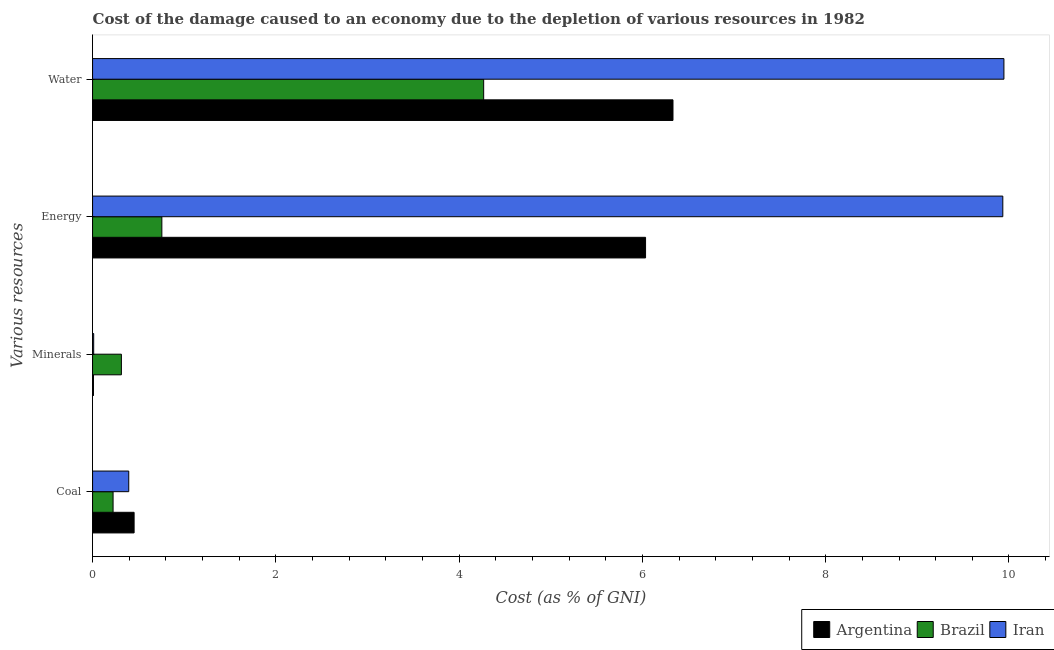How many bars are there on the 4th tick from the top?
Offer a very short reply. 3. What is the label of the 4th group of bars from the top?
Offer a terse response. Coal. What is the cost of damage due to depletion of coal in Iran?
Your response must be concise. 0.39. Across all countries, what is the maximum cost of damage due to depletion of minerals?
Keep it short and to the point. 0.31. Across all countries, what is the minimum cost of damage due to depletion of coal?
Provide a short and direct response. 0.22. In which country was the cost of damage due to depletion of minerals maximum?
Your response must be concise. Brazil. What is the total cost of damage due to depletion of coal in the graph?
Keep it short and to the point. 1.07. What is the difference between the cost of damage due to depletion of energy in Argentina and that in Iran?
Offer a terse response. -3.9. What is the difference between the cost of damage due to depletion of coal in Brazil and the cost of damage due to depletion of minerals in Argentina?
Your answer should be very brief. 0.21. What is the average cost of damage due to depletion of coal per country?
Provide a succinct answer. 0.36. What is the difference between the cost of damage due to depletion of water and cost of damage due to depletion of energy in Argentina?
Ensure brevity in your answer.  0.3. What is the ratio of the cost of damage due to depletion of coal in Brazil to that in Iran?
Make the answer very short. 0.57. Is the cost of damage due to depletion of minerals in Brazil less than that in Iran?
Provide a succinct answer. No. Is the difference between the cost of damage due to depletion of coal in Brazil and Argentina greater than the difference between the cost of damage due to depletion of minerals in Brazil and Argentina?
Ensure brevity in your answer.  No. What is the difference between the highest and the second highest cost of damage due to depletion of minerals?
Offer a very short reply. 0.3. What is the difference between the highest and the lowest cost of damage due to depletion of water?
Your answer should be very brief. 5.68. What does the 1st bar from the top in Minerals represents?
Your response must be concise. Iran. What does the 1st bar from the bottom in Water represents?
Offer a very short reply. Argentina. Is it the case that in every country, the sum of the cost of damage due to depletion of coal and cost of damage due to depletion of minerals is greater than the cost of damage due to depletion of energy?
Give a very brief answer. No. Are all the bars in the graph horizontal?
Ensure brevity in your answer.  Yes. How many countries are there in the graph?
Keep it short and to the point. 3. What is the difference between two consecutive major ticks on the X-axis?
Provide a short and direct response. 2. Does the graph contain grids?
Your response must be concise. No. What is the title of the graph?
Make the answer very short. Cost of the damage caused to an economy due to the depletion of various resources in 1982 . What is the label or title of the X-axis?
Make the answer very short. Cost (as % of GNI). What is the label or title of the Y-axis?
Provide a short and direct response. Various resources. What is the Cost (as % of GNI) in Argentina in Coal?
Provide a succinct answer. 0.45. What is the Cost (as % of GNI) in Brazil in Coal?
Your answer should be compact. 0.22. What is the Cost (as % of GNI) in Iran in Coal?
Offer a very short reply. 0.39. What is the Cost (as % of GNI) in Argentina in Minerals?
Keep it short and to the point. 0.01. What is the Cost (as % of GNI) of Brazil in Minerals?
Offer a terse response. 0.31. What is the Cost (as % of GNI) of Iran in Minerals?
Keep it short and to the point. 0.01. What is the Cost (as % of GNI) in Argentina in Energy?
Offer a very short reply. 6.03. What is the Cost (as % of GNI) of Brazil in Energy?
Ensure brevity in your answer.  0.76. What is the Cost (as % of GNI) of Iran in Energy?
Provide a succinct answer. 9.93. What is the Cost (as % of GNI) in Argentina in Water?
Your response must be concise. 6.33. What is the Cost (as % of GNI) in Brazil in Water?
Your answer should be very brief. 4.27. What is the Cost (as % of GNI) in Iran in Water?
Keep it short and to the point. 9.94. Across all Various resources, what is the maximum Cost (as % of GNI) in Argentina?
Make the answer very short. 6.33. Across all Various resources, what is the maximum Cost (as % of GNI) in Brazil?
Give a very brief answer. 4.27. Across all Various resources, what is the maximum Cost (as % of GNI) in Iran?
Offer a very short reply. 9.94. Across all Various resources, what is the minimum Cost (as % of GNI) of Argentina?
Your response must be concise. 0.01. Across all Various resources, what is the minimum Cost (as % of GNI) in Brazil?
Provide a succinct answer. 0.22. Across all Various resources, what is the minimum Cost (as % of GNI) of Iran?
Ensure brevity in your answer.  0.01. What is the total Cost (as % of GNI) in Argentina in the graph?
Your answer should be compact. 12.83. What is the total Cost (as % of GNI) in Brazil in the graph?
Offer a terse response. 5.56. What is the total Cost (as % of GNI) of Iran in the graph?
Make the answer very short. 20.28. What is the difference between the Cost (as % of GNI) of Argentina in Coal and that in Minerals?
Your response must be concise. 0.44. What is the difference between the Cost (as % of GNI) of Brazil in Coal and that in Minerals?
Ensure brevity in your answer.  -0.09. What is the difference between the Cost (as % of GNI) in Iran in Coal and that in Minerals?
Your answer should be very brief. 0.38. What is the difference between the Cost (as % of GNI) in Argentina in Coal and that in Energy?
Provide a succinct answer. -5.58. What is the difference between the Cost (as % of GNI) in Brazil in Coal and that in Energy?
Keep it short and to the point. -0.53. What is the difference between the Cost (as % of GNI) of Iran in Coal and that in Energy?
Provide a succinct answer. -9.54. What is the difference between the Cost (as % of GNI) in Argentina in Coal and that in Water?
Make the answer very short. -5.88. What is the difference between the Cost (as % of GNI) of Brazil in Coal and that in Water?
Make the answer very short. -4.04. What is the difference between the Cost (as % of GNI) in Iran in Coal and that in Water?
Your response must be concise. -9.55. What is the difference between the Cost (as % of GNI) of Argentina in Minerals and that in Energy?
Keep it short and to the point. -6.02. What is the difference between the Cost (as % of GNI) of Brazil in Minerals and that in Energy?
Make the answer very short. -0.44. What is the difference between the Cost (as % of GNI) of Iran in Minerals and that in Energy?
Provide a succinct answer. -9.92. What is the difference between the Cost (as % of GNI) of Argentina in Minerals and that in Water?
Offer a terse response. -6.32. What is the difference between the Cost (as % of GNI) in Brazil in Minerals and that in Water?
Your response must be concise. -3.95. What is the difference between the Cost (as % of GNI) of Iran in Minerals and that in Water?
Your response must be concise. -9.93. What is the difference between the Cost (as % of GNI) in Argentina in Energy and that in Water?
Provide a short and direct response. -0.3. What is the difference between the Cost (as % of GNI) of Brazil in Energy and that in Water?
Your response must be concise. -3.51. What is the difference between the Cost (as % of GNI) in Iran in Energy and that in Water?
Provide a short and direct response. -0.01. What is the difference between the Cost (as % of GNI) of Argentina in Coal and the Cost (as % of GNI) of Brazil in Minerals?
Ensure brevity in your answer.  0.14. What is the difference between the Cost (as % of GNI) of Argentina in Coal and the Cost (as % of GNI) of Iran in Minerals?
Make the answer very short. 0.44. What is the difference between the Cost (as % of GNI) of Brazil in Coal and the Cost (as % of GNI) of Iran in Minerals?
Offer a very short reply. 0.21. What is the difference between the Cost (as % of GNI) of Argentina in Coal and the Cost (as % of GNI) of Brazil in Energy?
Offer a very short reply. -0.3. What is the difference between the Cost (as % of GNI) of Argentina in Coal and the Cost (as % of GNI) of Iran in Energy?
Make the answer very short. -9.48. What is the difference between the Cost (as % of GNI) in Brazil in Coal and the Cost (as % of GNI) in Iran in Energy?
Provide a succinct answer. -9.71. What is the difference between the Cost (as % of GNI) in Argentina in Coal and the Cost (as % of GNI) in Brazil in Water?
Provide a short and direct response. -3.81. What is the difference between the Cost (as % of GNI) in Argentina in Coal and the Cost (as % of GNI) in Iran in Water?
Keep it short and to the point. -9.49. What is the difference between the Cost (as % of GNI) of Brazil in Coal and the Cost (as % of GNI) of Iran in Water?
Offer a terse response. -9.72. What is the difference between the Cost (as % of GNI) of Argentina in Minerals and the Cost (as % of GNI) of Brazil in Energy?
Your answer should be compact. -0.75. What is the difference between the Cost (as % of GNI) in Argentina in Minerals and the Cost (as % of GNI) in Iran in Energy?
Your answer should be compact. -9.92. What is the difference between the Cost (as % of GNI) of Brazil in Minerals and the Cost (as % of GNI) of Iran in Energy?
Provide a succinct answer. -9.62. What is the difference between the Cost (as % of GNI) of Argentina in Minerals and the Cost (as % of GNI) of Brazil in Water?
Make the answer very short. -4.26. What is the difference between the Cost (as % of GNI) in Argentina in Minerals and the Cost (as % of GNI) in Iran in Water?
Keep it short and to the point. -9.94. What is the difference between the Cost (as % of GNI) in Brazil in Minerals and the Cost (as % of GNI) in Iran in Water?
Your answer should be very brief. -9.63. What is the difference between the Cost (as % of GNI) in Argentina in Energy and the Cost (as % of GNI) in Brazil in Water?
Your answer should be compact. 1.77. What is the difference between the Cost (as % of GNI) of Argentina in Energy and the Cost (as % of GNI) of Iran in Water?
Offer a very short reply. -3.91. What is the difference between the Cost (as % of GNI) of Brazil in Energy and the Cost (as % of GNI) of Iran in Water?
Your answer should be very brief. -9.19. What is the average Cost (as % of GNI) of Argentina per Various resources?
Ensure brevity in your answer.  3.21. What is the average Cost (as % of GNI) in Brazil per Various resources?
Your answer should be very brief. 1.39. What is the average Cost (as % of GNI) in Iran per Various resources?
Offer a very short reply. 5.07. What is the difference between the Cost (as % of GNI) in Argentina and Cost (as % of GNI) in Brazil in Coal?
Give a very brief answer. 0.23. What is the difference between the Cost (as % of GNI) of Argentina and Cost (as % of GNI) of Iran in Coal?
Your response must be concise. 0.06. What is the difference between the Cost (as % of GNI) of Brazil and Cost (as % of GNI) of Iran in Coal?
Keep it short and to the point. -0.17. What is the difference between the Cost (as % of GNI) of Argentina and Cost (as % of GNI) of Brazil in Minerals?
Ensure brevity in your answer.  -0.3. What is the difference between the Cost (as % of GNI) in Argentina and Cost (as % of GNI) in Iran in Minerals?
Give a very brief answer. -0. What is the difference between the Cost (as % of GNI) in Brazil and Cost (as % of GNI) in Iran in Minerals?
Offer a terse response. 0.3. What is the difference between the Cost (as % of GNI) in Argentina and Cost (as % of GNI) in Brazil in Energy?
Your response must be concise. 5.28. What is the difference between the Cost (as % of GNI) of Argentina and Cost (as % of GNI) of Iran in Energy?
Keep it short and to the point. -3.9. What is the difference between the Cost (as % of GNI) of Brazil and Cost (as % of GNI) of Iran in Energy?
Provide a succinct answer. -9.18. What is the difference between the Cost (as % of GNI) in Argentina and Cost (as % of GNI) in Brazil in Water?
Provide a succinct answer. 2.07. What is the difference between the Cost (as % of GNI) in Argentina and Cost (as % of GNI) in Iran in Water?
Give a very brief answer. -3.61. What is the difference between the Cost (as % of GNI) of Brazil and Cost (as % of GNI) of Iran in Water?
Make the answer very short. -5.68. What is the ratio of the Cost (as % of GNI) of Argentina in Coal to that in Minerals?
Offer a terse response. 45.7. What is the ratio of the Cost (as % of GNI) in Brazil in Coal to that in Minerals?
Give a very brief answer. 0.71. What is the ratio of the Cost (as % of GNI) of Iran in Coal to that in Minerals?
Your answer should be compact. 32.41. What is the ratio of the Cost (as % of GNI) of Argentina in Coal to that in Energy?
Ensure brevity in your answer.  0.08. What is the ratio of the Cost (as % of GNI) in Brazil in Coal to that in Energy?
Your answer should be compact. 0.3. What is the ratio of the Cost (as % of GNI) of Iran in Coal to that in Energy?
Provide a succinct answer. 0.04. What is the ratio of the Cost (as % of GNI) of Argentina in Coal to that in Water?
Make the answer very short. 0.07. What is the ratio of the Cost (as % of GNI) in Brazil in Coal to that in Water?
Give a very brief answer. 0.05. What is the ratio of the Cost (as % of GNI) of Iran in Coal to that in Water?
Your answer should be compact. 0.04. What is the ratio of the Cost (as % of GNI) in Argentina in Minerals to that in Energy?
Your response must be concise. 0. What is the ratio of the Cost (as % of GNI) in Brazil in Minerals to that in Energy?
Make the answer very short. 0.42. What is the ratio of the Cost (as % of GNI) in Iran in Minerals to that in Energy?
Ensure brevity in your answer.  0. What is the ratio of the Cost (as % of GNI) of Argentina in Minerals to that in Water?
Your answer should be compact. 0. What is the ratio of the Cost (as % of GNI) of Brazil in Minerals to that in Water?
Your answer should be compact. 0.07. What is the ratio of the Cost (as % of GNI) in Iran in Minerals to that in Water?
Provide a succinct answer. 0. What is the ratio of the Cost (as % of GNI) in Argentina in Energy to that in Water?
Offer a terse response. 0.95. What is the ratio of the Cost (as % of GNI) of Brazil in Energy to that in Water?
Your response must be concise. 0.18. What is the ratio of the Cost (as % of GNI) in Iran in Energy to that in Water?
Keep it short and to the point. 1. What is the difference between the highest and the second highest Cost (as % of GNI) of Argentina?
Offer a very short reply. 0.3. What is the difference between the highest and the second highest Cost (as % of GNI) in Brazil?
Provide a succinct answer. 3.51. What is the difference between the highest and the second highest Cost (as % of GNI) of Iran?
Provide a short and direct response. 0.01. What is the difference between the highest and the lowest Cost (as % of GNI) in Argentina?
Keep it short and to the point. 6.32. What is the difference between the highest and the lowest Cost (as % of GNI) of Brazil?
Your answer should be very brief. 4.04. What is the difference between the highest and the lowest Cost (as % of GNI) in Iran?
Keep it short and to the point. 9.93. 